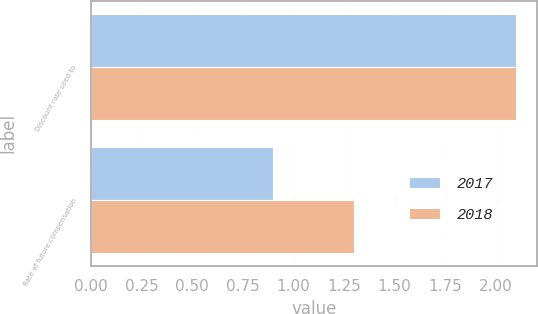Convert chart. <chart><loc_0><loc_0><loc_500><loc_500><stacked_bar_chart><ecel><fcel>Discount rate used to<fcel>Rate of future compensation<nl><fcel>2017<fcel>2.1<fcel>0.9<nl><fcel>2018<fcel>2.1<fcel>1.3<nl></chart> 